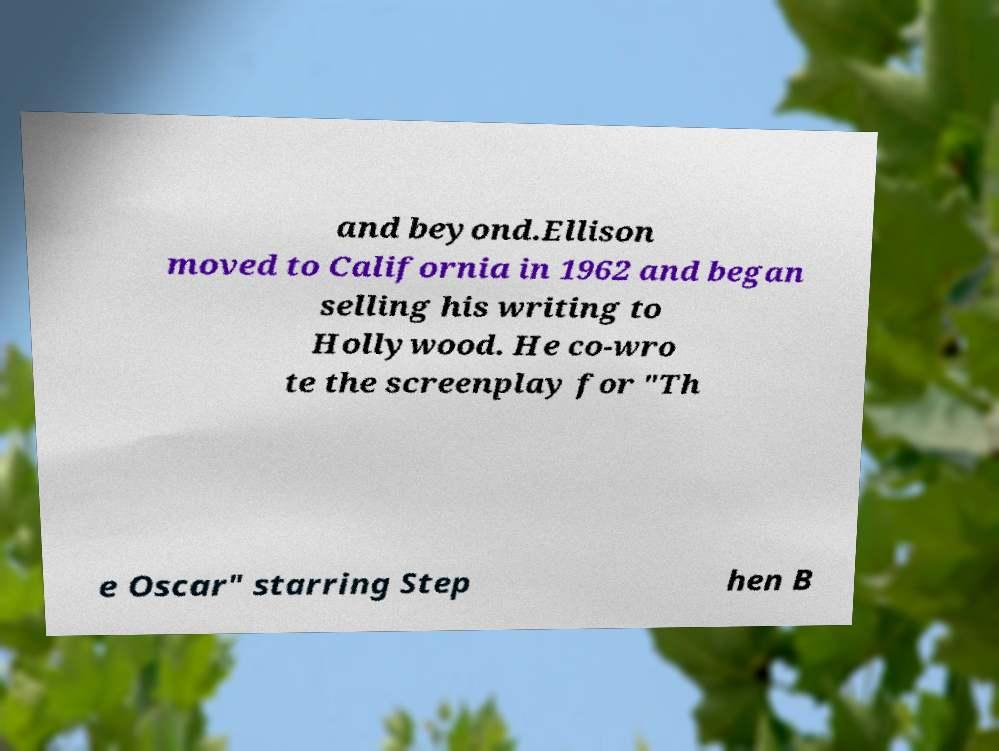I need the written content from this picture converted into text. Can you do that? and beyond.Ellison moved to California in 1962 and began selling his writing to Hollywood. He co-wro te the screenplay for "Th e Oscar" starring Step hen B 